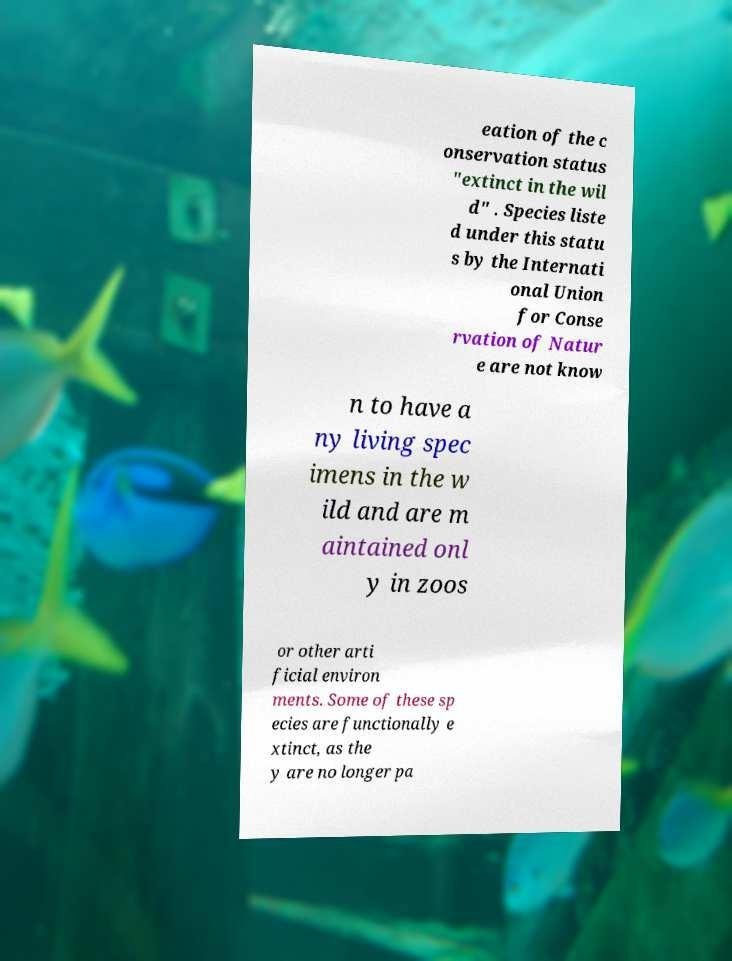Please identify and transcribe the text found in this image. eation of the c onservation status "extinct in the wil d" . Species liste d under this statu s by the Internati onal Union for Conse rvation of Natur e are not know n to have a ny living spec imens in the w ild and are m aintained onl y in zoos or other arti ficial environ ments. Some of these sp ecies are functionally e xtinct, as the y are no longer pa 